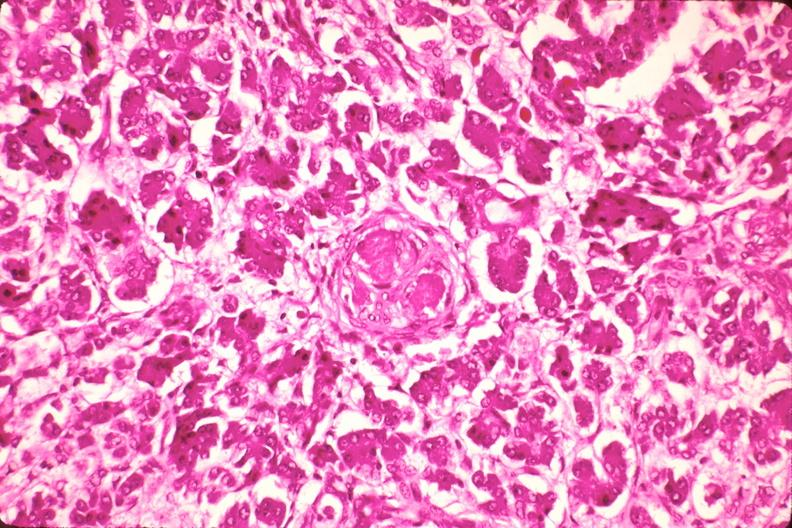does this image show pancreas, microthrombi, thrombotic thrombocytopenic purpura?
Answer the question using a single word or phrase. Yes 